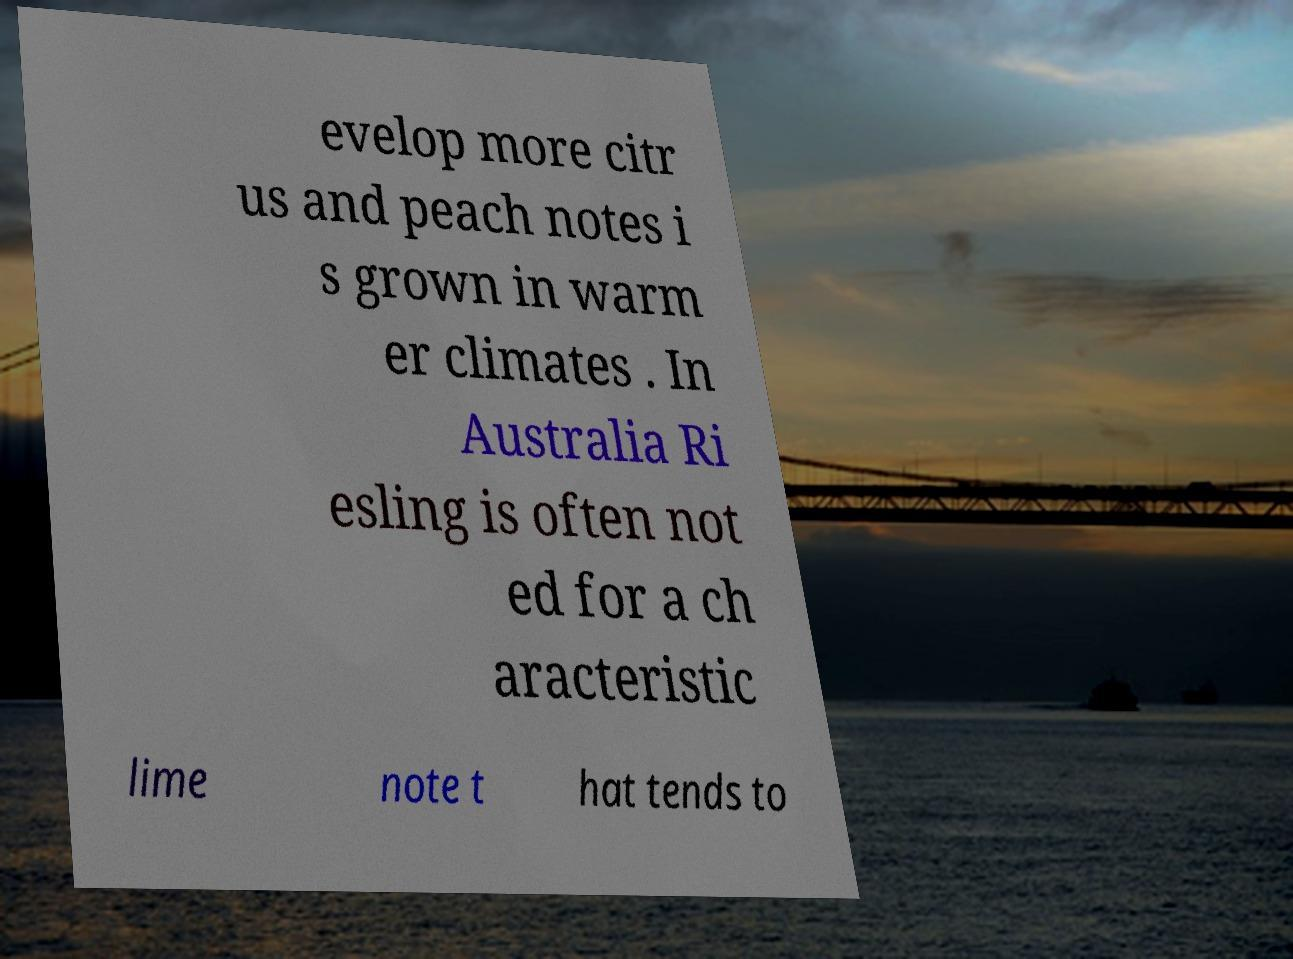Could you extract and type out the text from this image? evelop more citr us and peach notes i s grown in warm er climates . In Australia Ri esling is often not ed for a ch aracteristic lime note t hat tends to 